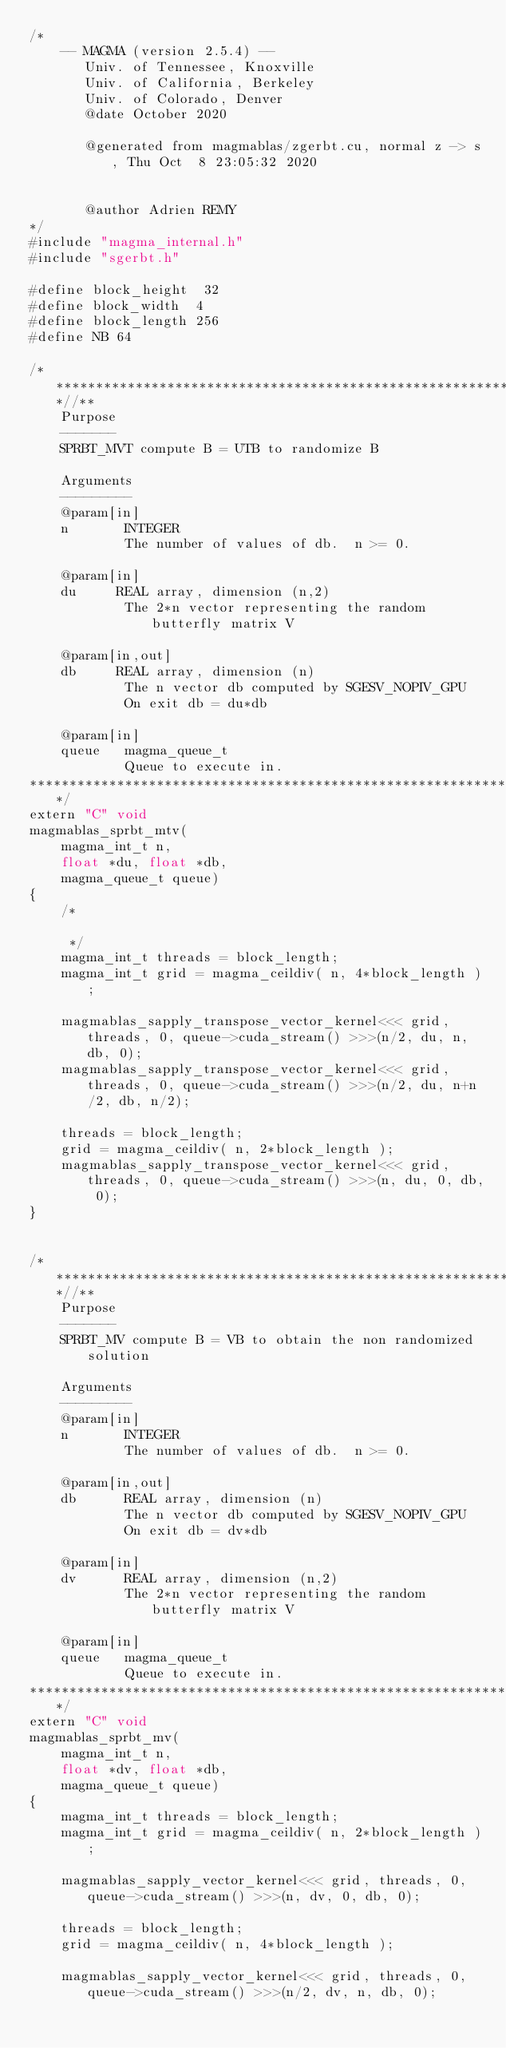Convert code to text. <code><loc_0><loc_0><loc_500><loc_500><_Cuda_>/*
    -- MAGMA (version 2.5.4) --
       Univ. of Tennessee, Knoxville
       Univ. of California, Berkeley
       Univ. of Colorado, Denver
       @date October 2020

       @generated from magmablas/zgerbt.cu, normal z -> s, Thu Oct  8 23:05:32 2020


       @author Adrien REMY
*/
#include "magma_internal.h"
#include "sgerbt.h"

#define block_height  32
#define block_width  4
#define block_length 256
#define NB 64

/***************************************************************************//**
    Purpose
    -------
    SPRBT_MVT compute B = UTB to randomize B
    
    Arguments
    ---------
    @param[in]
    n       INTEGER
            The number of values of db.  n >= 0.

    @param[in]
    du     REAL array, dimension (n,2)
            The 2*n vector representing the random butterfly matrix V
    
    @param[in,out]
    db     REAL array, dimension (n)
            The n vector db computed by SGESV_NOPIV_GPU
            On exit db = du*db
    
    @param[in]
    queue   magma_queue_t
            Queue to execute in.
*******************************************************************************/
extern "C" void
magmablas_sprbt_mtv(
    magma_int_t n, 
    float *du, float *db,
    magma_queue_t queue)
{
    /*

     */
    magma_int_t threads = block_length;
    magma_int_t grid = magma_ceildiv( n, 4*block_length );

    magmablas_sapply_transpose_vector_kernel<<< grid, threads, 0, queue->cuda_stream() >>>(n/2, du, n, db, 0);
    magmablas_sapply_transpose_vector_kernel<<< grid, threads, 0, queue->cuda_stream() >>>(n/2, du, n+n/2, db, n/2);

    threads = block_length;
    grid = magma_ceildiv( n, 2*block_length );
    magmablas_sapply_transpose_vector_kernel<<< grid, threads, 0, queue->cuda_stream() >>>(n, du, 0, db, 0);
}


/***************************************************************************//**
    Purpose
    -------
    SPRBT_MV compute B = VB to obtain the non randomized solution
    
    Arguments
    ---------
    @param[in]
    n       INTEGER
            The number of values of db.  n >= 0.
    
    @param[in,out]
    db      REAL array, dimension (n)
            The n vector db computed by SGESV_NOPIV_GPU
            On exit db = dv*db
    
    @param[in]
    dv      REAL array, dimension (n,2)
            The 2*n vector representing the random butterfly matrix V
    
    @param[in]
    queue   magma_queue_t
            Queue to execute in.
*******************************************************************************/
extern "C" void
magmablas_sprbt_mv(
    magma_int_t n, 
    float *dv, float *db,
    magma_queue_t queue)
{
    magma_int_t threads = block_length;
    magma_int_t grid = magma_ceildiv( n, 2*block_length );

    magmablas_sapply_vector_kernel<<< grid, threads, 0, queue->cuda_stream() >>>(n, dv, 0, db, 0);

    threads = block_length;
    grid = magma_ceildiv( n, 4*block_length );

    magmablas_sapply_vector_kernel<<< grid, threads, 0, queue->cuda_stream() >>>(n/2, dv, n, db, 0);</code> 